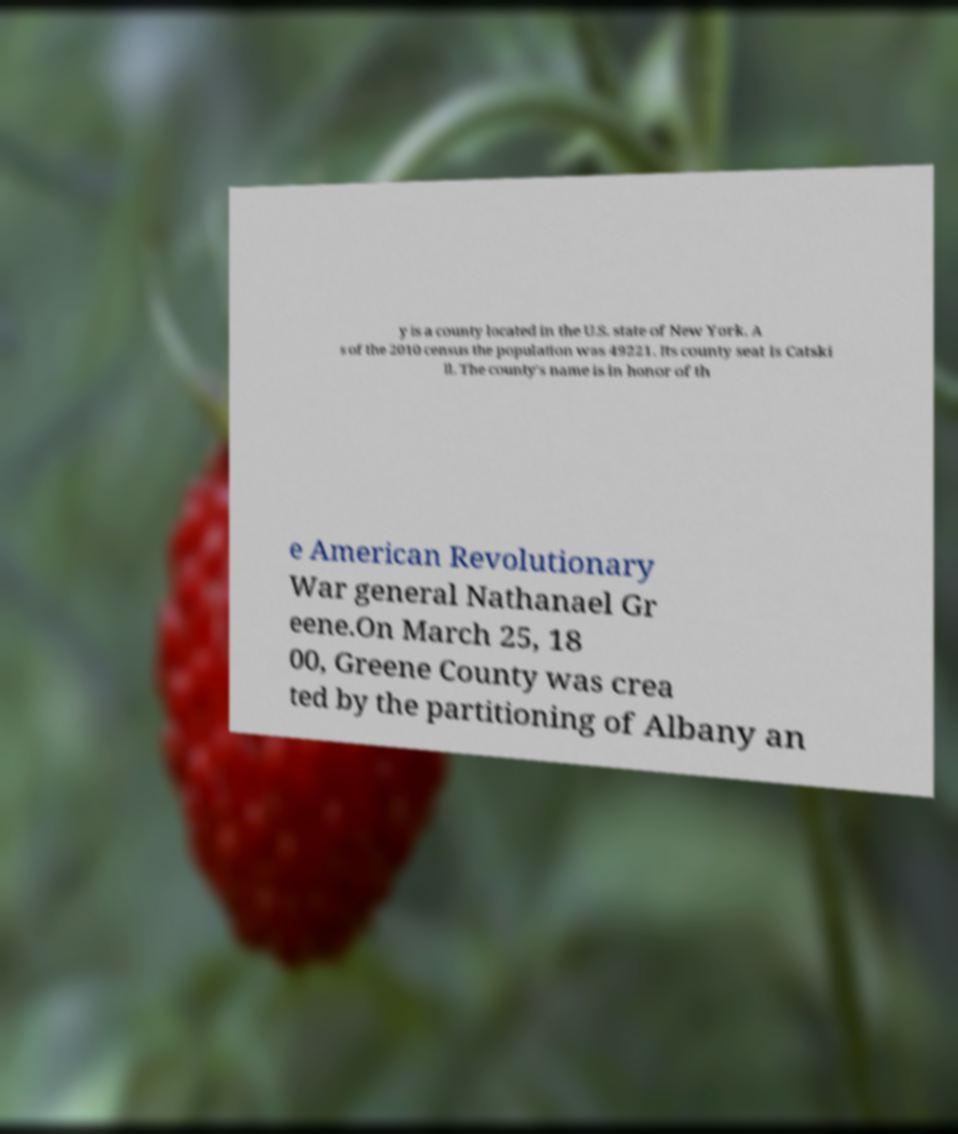Please read and relay the text visible in this image. What does it say? y is a county located in the U.S. state of New York. A s of the 2010 census the population was 49221. Its county seat is Catski ll. The county's name is in honor of th e American Revolutionary War general Nathanael Gr eene.On March 25, 18 00, Greene County was crea ted by the partitioning of Albany an 